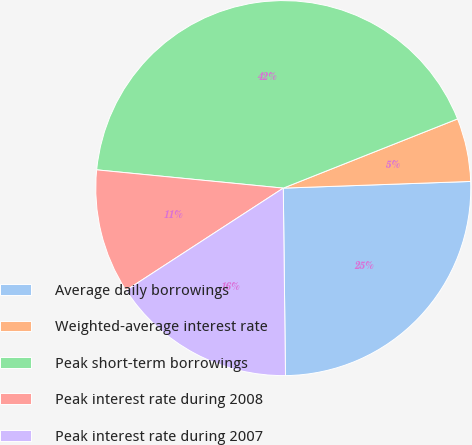Convert chart. <chart><loc_0><loc_0><loc_500><loc_500><pie_chart><fcel>Average daily borrowings<fcel>Weighted-average interest rate<fcel>Peak short-term borrowings<fcel>Peak interest rate during 2008<fcel>Peak interest rate during 2007<nl><fcel>25.38%<fcel>5.45%<fcel>42.43%<fcel>10.73%<fcel>16.01%<nl></chart> 